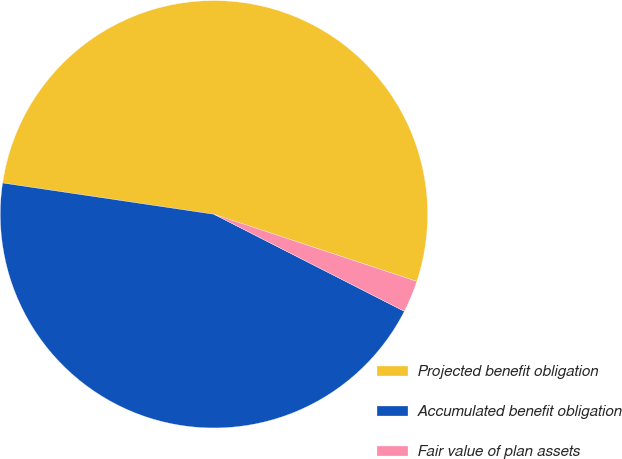Convert chart to OTSL. <chart><loc_0><loc_0><loc_500><loc_500><pie_chart><fcel>Projected benefit obligation<fcel>Accumulated benefit obligation<fcel>Fair value of plan assets<nl><fcel>52.75%<fcel>44.84%<fcel>2.42%<nl></chart> 